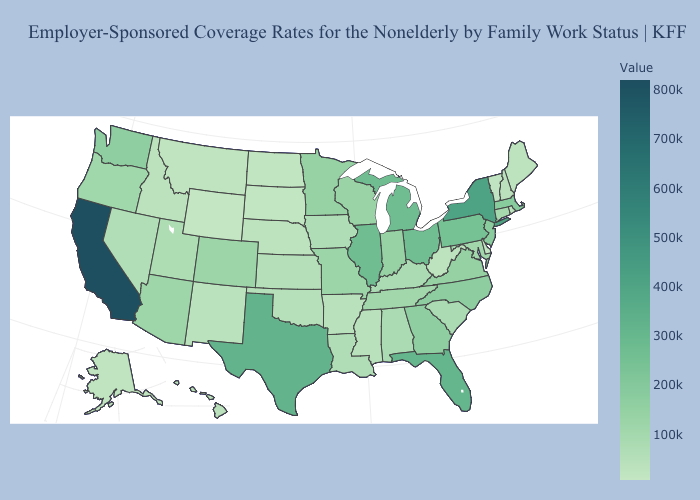Which states have the lowest value in the MidWest?
Quick response, please. South Dakota. Does Hawaii have the highest value in the West?
Short answer required. No. Does Alaska have the lowest value in the West?
Keep it brief. No. Which states have the lowest value in the MidWest?
Quick response, please. South Dakota. 